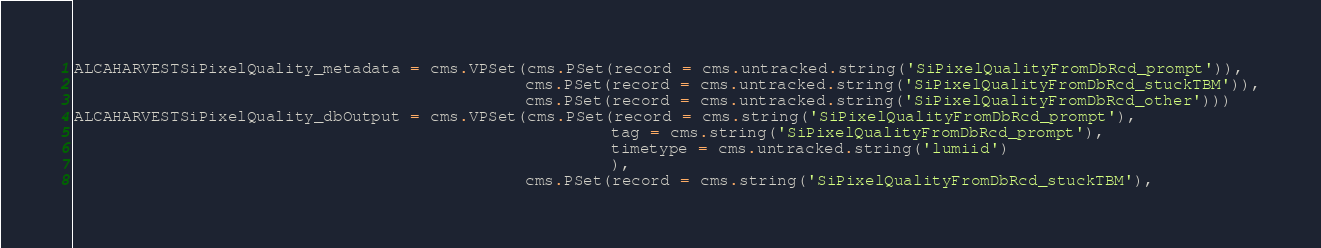Convert code to text. <code><loc_0><loc_0><loc_500><loc_500><_Python_>ALCAHARVESTSiPixelQuality_metadata = cms.VPSet(cms.PSet(record = cms.untracked.string('SiPixelQualityFromDbRcd_prompt')),
                                               cms.PSet(record = cms.untracked.string('SiPixelQualityFromDbRcd_stuckTBM')),
                                               cms.PSet(record = cms.untracked.string('SiPixelQualityFromDbRcd_other')))
ALCAHARVESTSiPixelQuality_dbOutput = cms.VPSet(cms.PSet(record = cms.string('SiPixelQualityFromDbRcd_prompt'),
                                                        tag = cms.string('SiPixelQualityFromDbRcd_prompt'),
                                                        timetype = cms.untracked.string('lumiid')
                                                        ),
                                               cms.PSet(record = cms.string('SiPixelQualityFromDbRcd_stuckTBM'),</code> 